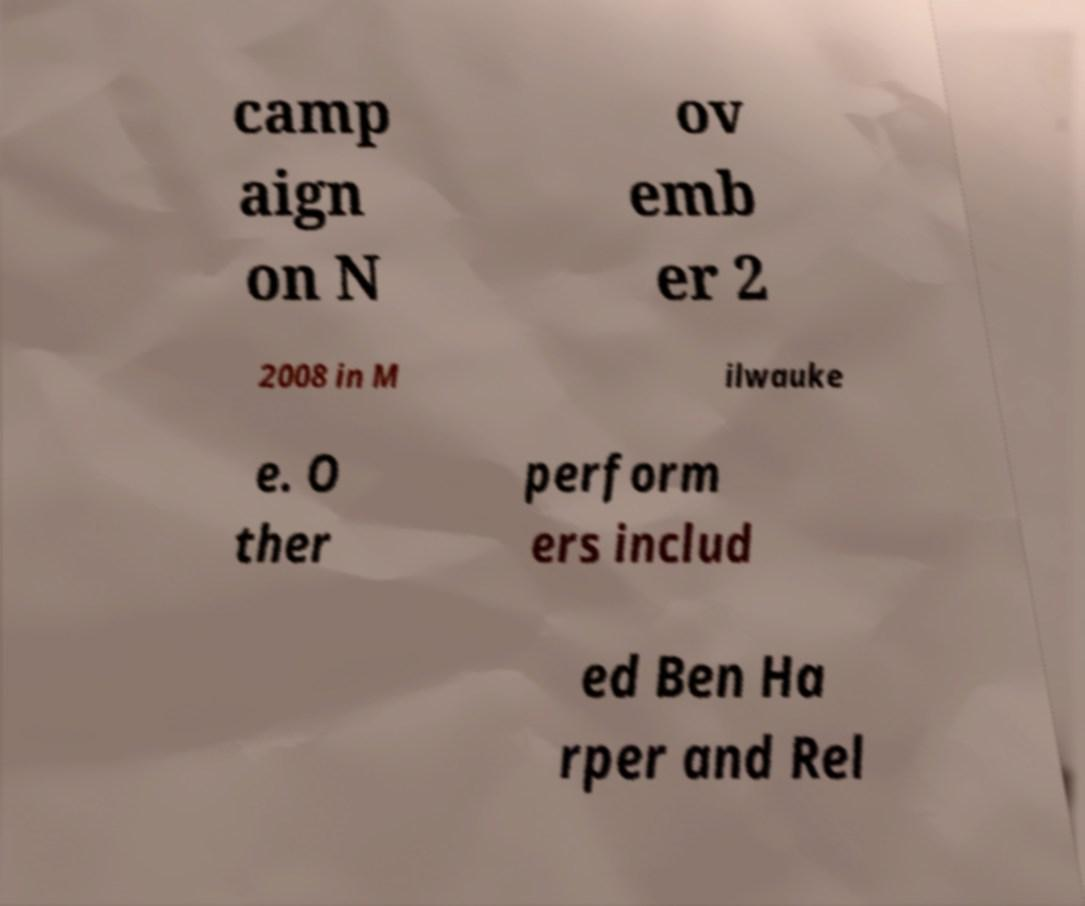For documentation purposes, I need the text within this image transcribed. Could you provide that? camp aign on N ov emb er 2 2008 in M ilwauke e. O ther perform ers includ ed Ben Ha rper and Rel 